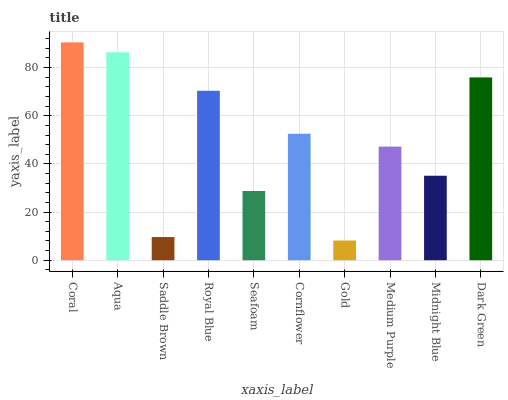Is Gold the minimum?
Answer yes or no. Yes. Is Coral the maximum?
Answer yes or no. Yes. Is Aqua the minimum?
Answer yes or no. No. Is Aqua the maximum?
Answer yes or no. No. Is Coral greater than Aqua?
Answer yes or no. Yes. Is Aqua less than Coral?
Answer yes or no. Yes. Is Aqua greater than Coral?
Answer yes or no. No. Is Coral less than Aqua?
Answer yes or no. No. Is Cornflower the high median?
Answer yes or no. Yes. Is Medium Purple the low median?
Answer yes or no. Yes. Is Medium Purple the high median?
Answer yes or no. No. Is Royal Blue the low median?
Answer yes or no. No. 